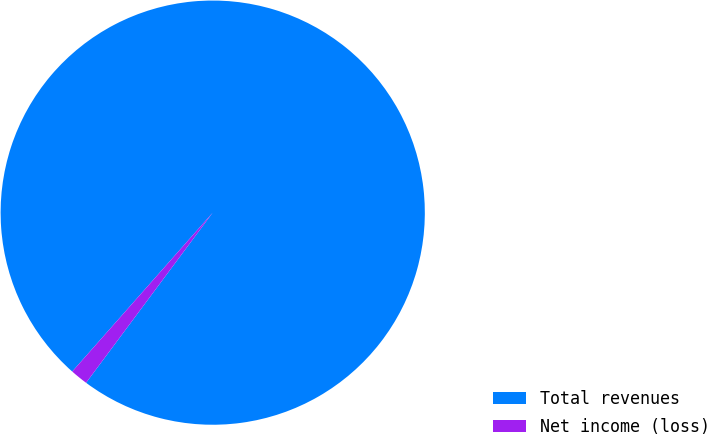Convert chart. <chart><loc_0><loc_0><loc_500><loc_500><pie_chart><fcel>Total revenues<fcel>Net income (loss)<nl><fcel>98.66%<fcel>1.34%<nl></chart> 